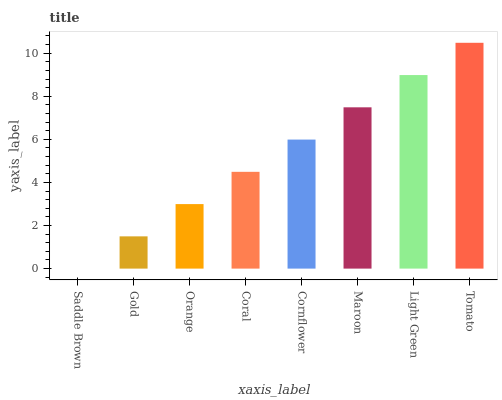Is Saddle Brown the minimum?
Answer yes or no. Yes. Is Tomato the maximum?
Answer yes or no. Yes. Is Gold the minimum?
Answer yes or no. No. Is Gold the maximum?
Answer yes or no. No. Is Gold greater than Saddle Brown?
Answer yes or no. Yes. Is Saddle Brown less than Gold?
Answer yes or no. Yes. Is Saddle Brown greater than Gold?
Answer yes or no. No. Is Gold less than Saddle Brown?
Answer yes or no. No. Is Cornflower the high median?
Answer yes or no. Yes. Is Coral the low median?
Answer yes or no. Yes. Is Coral the high median?
Answer yes or no. No. Is Cornflower the low median?
Answer yes or no. No. 